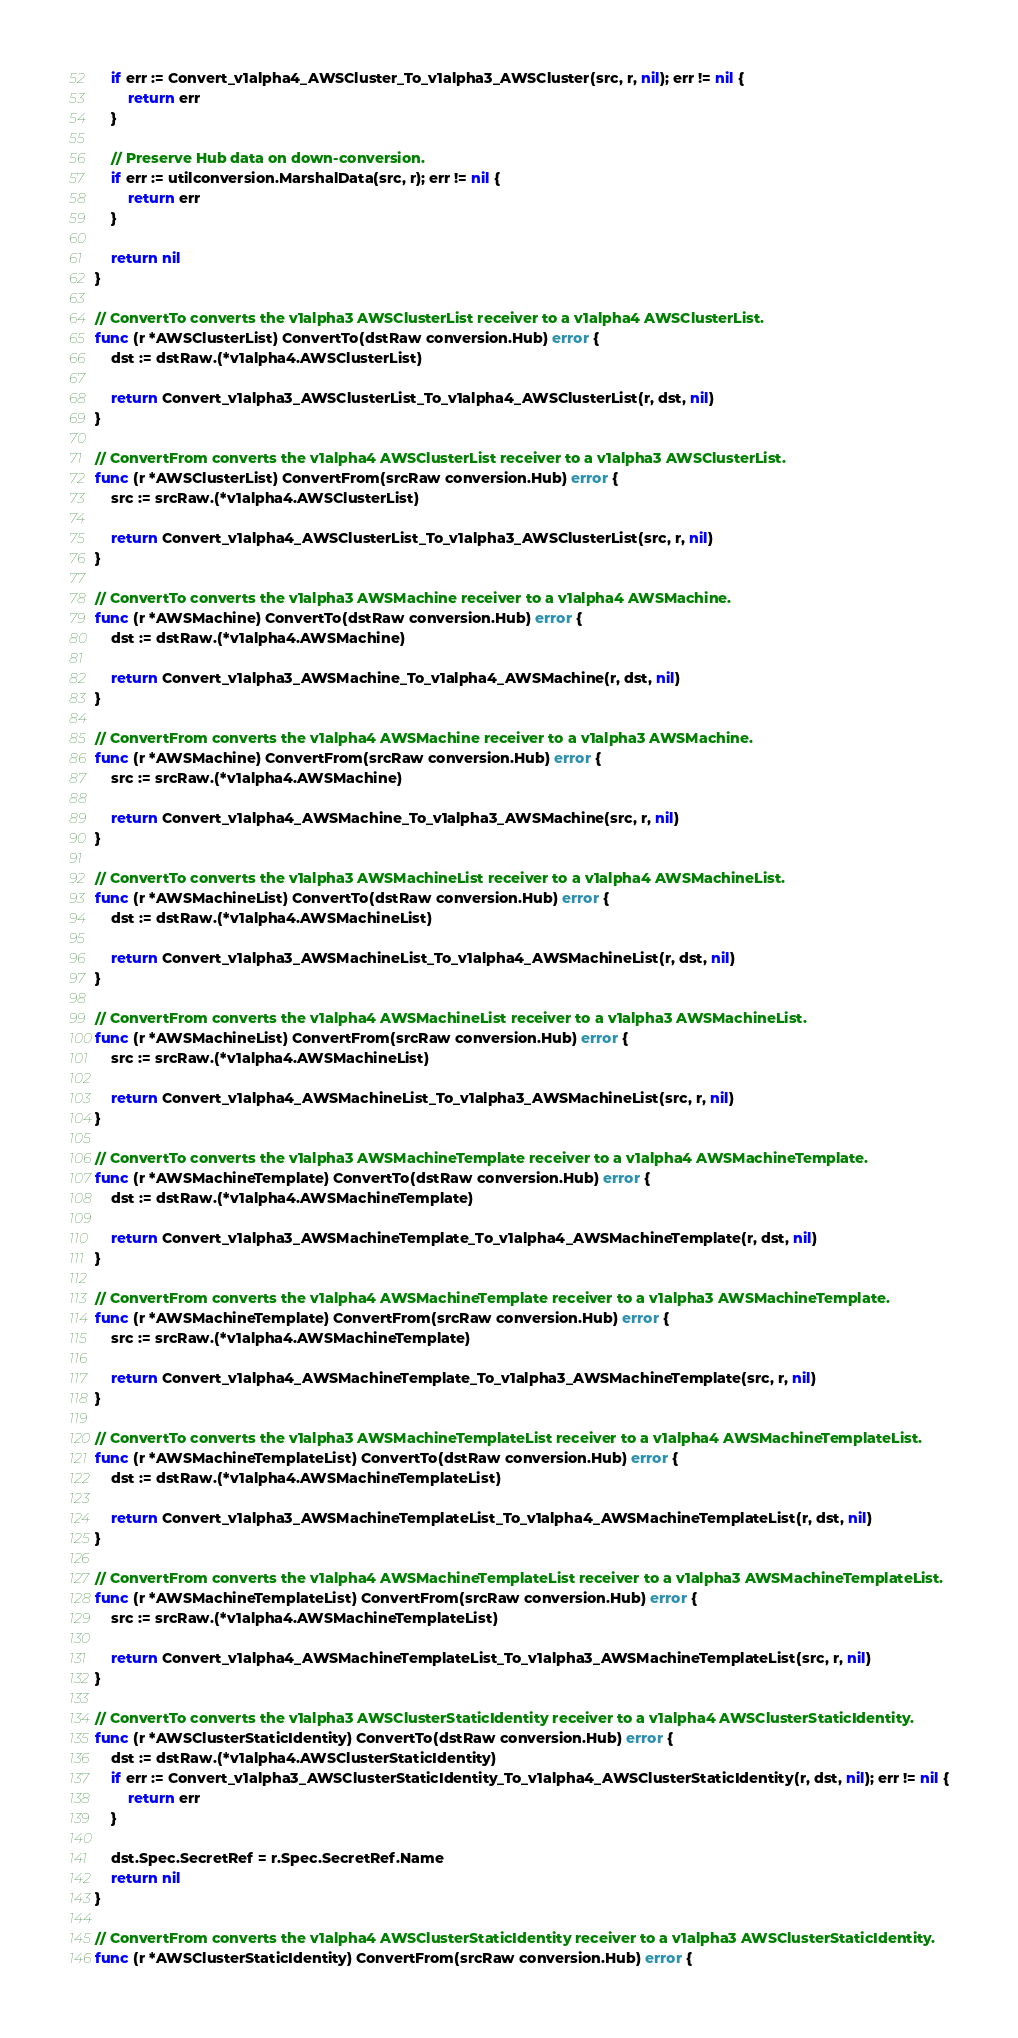<code> <loc_0><loc_0><loc_500><loc_500><_Go_>	if err := Convert_v1alpha4_AWSCluster_To_v1alpha3_AWSCluster(src, r, nil); err != nil {
		return err
	}

	// Preserve Hub data on down-conversion.
	if err := utilconversion.MarshalData(src, r); err != nil {
		return err
	}

	return nil
}

// ConvertTo converts the v1alpha3 AWSClusterList receiver to a v1alpha4 AWSClusterList.
func (r *AWSClusterList) ConvertTo(dstRaw conversion.Hub) error {
	dst := dstRaw.(*v1alpha4.AWSClusterList)

	return Convert_v1alpha3_AWSClusterList_To_v1alpha4_AWSClusterList(r, dst, nil)
}

// ConvertFrom converts the v1alpha4 AWSClusterList receiver to a v1alpha3 AWSClusterList.
func (r *AWSClusterList) ConvertFrom(srcRaw conversion.Hub) error {
	src := srcRaw.(*v1alpha4.AWSClusterList)

	return Convert_v1alpha4_AWSClusterList_To_v1alpha3_AWSClusterList(src, r, nil)
}

// ConvertTo converts the v1alpha3 AWSMachine receiver to a v1alpha4 AWSMachine.
func (r *AWSMachine) ConvertTo(dstRaw conversion.Hub) error {
	dst := dstRaw.(*v1alpha4.AWSMachine)

	return Convert_v1alpha3_AWSMachine_To_v1alpha4_AWSMachine(r, dst, nil)
}

// ConvertFrom converts the v1alpha4 AWSMachine receiver to a v1alpha3 AWSMachine.
func (r *AWSMachine) ConvertFrom(srcRaw conversion.Hub) error {
	src := srcRaw.(*v1alpha4.AWSMachine)

	return Convert_v1alpha4_AWSMachine_To_v1alpha3_AWSMachine(src, r, nil)
}

// ConvertTo converts the v1alpha3 AWSMachineList receiver to a v1alpha4 AWSMachineList.
func (r *AWSMachineList) ConvertTo(dstRaw conversion.Hub) error {
	dst := dstRaw.(*v1alpha4.AWSMachineList)

	return Convert_v1alpha3_AWSMachineList_To_v1alpha4_AWSMachineList(r, dst, nil)
}

// ConvertFrom converts the v1alpha4 AWSMachineList receiver to a v1alpha3 AWSMachineList.
func (r *AWSMachineList) ConvertFrom(srcRaw conversion.Hub) error {
	src := srcRaw.(*v1alpha4.AWSMachineList)

	return Convert_v1alpha4_AWSMachineList_To_v1alpha3_AWSMachineList(src, r, nil)
}

// ConvertTo converts the v1alpha3 AWSMachineTemplate receiver to a v1alpha4 AWSMachineTemplate.
func (r *AWSMachineTemplate) ConvertTo(dstRaw conversion.Hub) error {
	dst := dstRaw.(*v1alpha4.AWSMachineTemplate)

	return Convert_v1alpha3_AWSMachineTemplate_To_v1alpha4_AWSMachineTemplate(r, dst, nil)
}

// ConvertFrom converts the v1alpha4 AWSMachineTemplate receiver to a v1alpha3 AWSMachineTemplate.
func (r *AWSMachineTemplate) ConvertFrom(srcRaw conversion.Hub) error {
	src := srcRaw.(*v1alpha4.AWSMachineTemplate)

	return Convert_v1alpha4_AWSMachineTemplate_To_v1alpha3_AWSMachineTemplate(src, r, nil)
}

// ConvertTo converts the v1alpha3 AWSMachineTemplateList receiver to a v1alpha4 AWSMachineTemplateList.
func (r *AWSMachineTemplateList) ConvertTo(dstRaw conversion.Hub) error {
	dst := dstRaw.(*v1alpha4.AWSMachineTemplateList)

	return Convert_v1alpha3_AWSMachineTemplateList_To_v1alpha4_AWSMachineTemplateList(r, dst, nil)
}

// ConvertFrom converts the v1alpha4 AWSMachineTemplateList receiver to a v1alpha3 AWSMachineTemplateList.
func (r *AWSMachineTemplateList) ConvertFrom(srcRaw conversion.Hub) error {
	src := srcRaw.(*v1alpha4.AWSMachineTemplateList)

	return Convert_v1alpha4_AWSMachineTemplateList_To_v1alpha3_AWSMachineTemplateList(src, r, nil)
}

// ConvertTo converts the v1alpha3 AWSClusterStaticIdentity receiver to a v1alpha4 AWSClusterStaticIdentity.
func (r *AWSClusterStaticIdentity) ConvertTo(dstRaw conversion.Hub) error {
	dst := dstRaw.(*v1alpha4.AWSClusterStaticIdentity)
	if err := Convert_v1alpha3_AWSClusterStaticIdentity_To_v1alpha4_AWSClusterStaticIdentity(r, dst, nil); err != nil {
		return err
	}

	dst.Spec.SecretRef = r.Spec.SecretRef.Name
	return nil
}

// ConvertFrom converts the v1alpha4 AWSClusterStaticIdentity receiver to a v1alpha3 AWSClusterStaticIdentity.
func (r *AWSClusterStaticIdentity) ConvertFrom(srcRaw conversion.Hub) error {</code> 